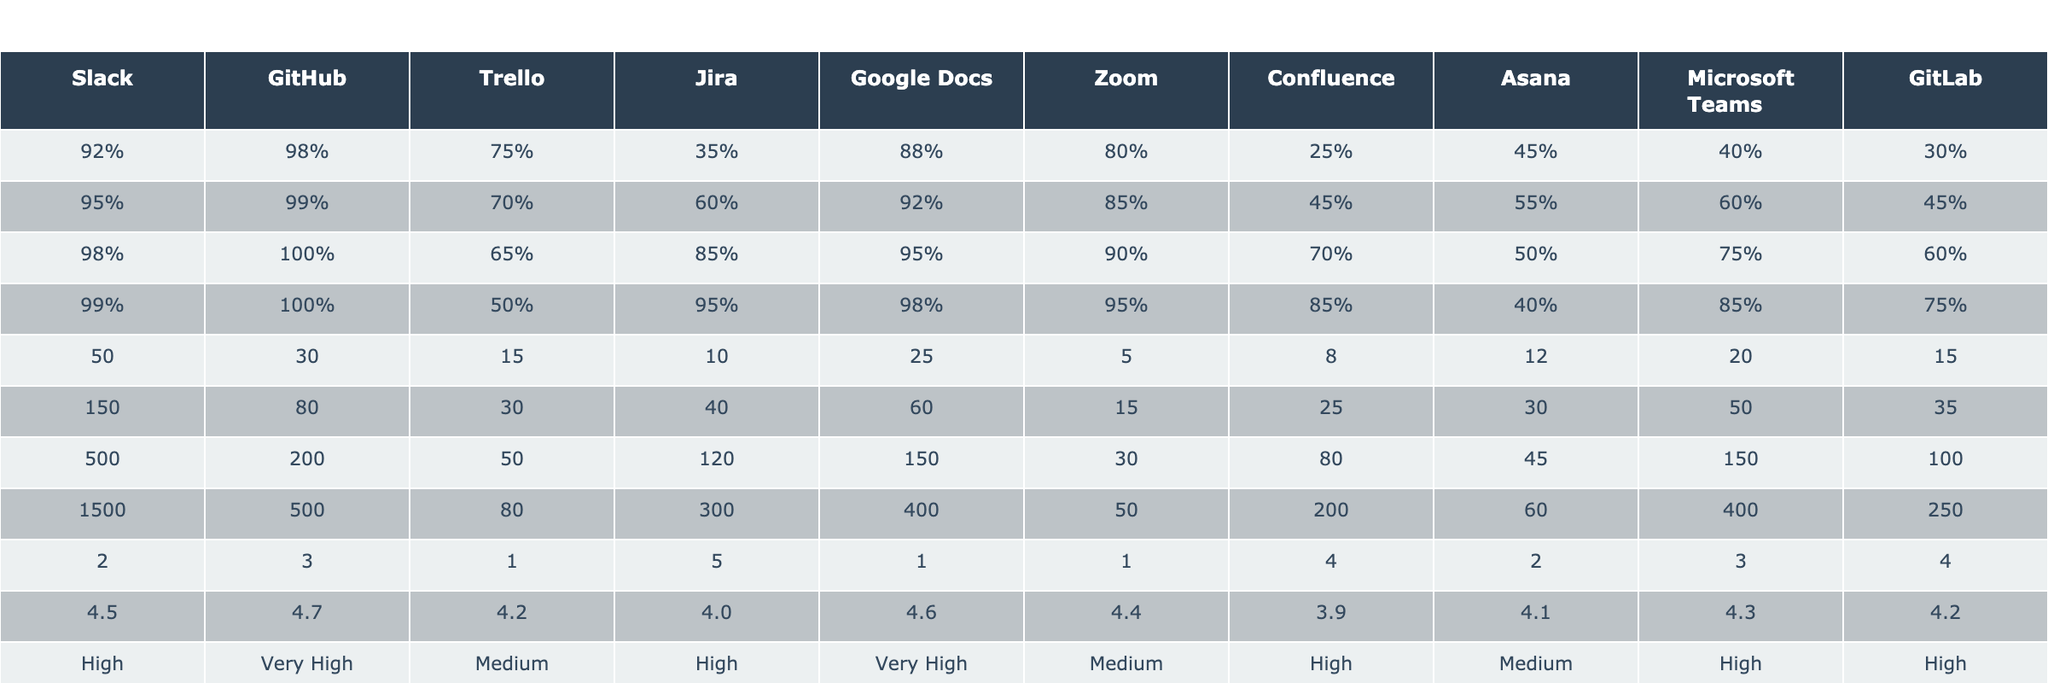What is the user satisfaction rating for Slack in small projects? According to the table, the user satisfaction rating for Slack is listed under the "User satisfaction rating" row for the "Small (1-10 members)" category, which shows a value of 4.5.
Answer: 4.5 Which collaboration tool has the highest percentage usage in enterprise projects? By looking at the percentage usage for each collaboration tool in the "Enterprise (201+ members)" row, Slack and GitHub both show a usage of 99% and 100% respectively, but GitHub has the highest at 100%.
Answer: GitHub What is the average daily number of messages for large projects using Trello? The table lists the average daily messages for Trello under the "Average daily messages" row for "Large (51-200 members)" and it shows a value of 50.
Answer: 50 Which project size has the lowest average onboarding time when using Google Docs? The onboarding times for Google Docs across project sizes are: 2 days for small, 1 day for medium, 1 day for large, and 1 day for enterprise. The smallest value is 1 day, which occurs in medium, large, and enterprise projects.
Answer: 1 day What is the difference in user satisfaction ratings between GitHub and Confluence for small projects? The user satisfaction rating for GitHub is 4.7 and for Confluence it is 3.9. The difference is calculated as 4.7 - 3.9 = 0.8.
Answer: 0.8 Is the integration of Asana with other tools rated high or medium? The table indicates that Asana's integration with other tools is categorized as "Medium."
Answer: Medium For medium-sized teams, which tool has both the highest average daily messages and a very high integration rating? The average daily messages for medium projects show Slack with 150 messages and its integration rating is "High." However, GitHub, with 80 messages, has a "Very High" integration rating. Therefore, Slack has the highest average daily messages.
Answer: Slack What is the average number of daily messages for small projects across all tools? The average daily messages for small projects are: Slack (50), GitHub (30), Trello (15), Jira (10), Google Docs (25), Zoom (5), Confluence (8), Asana (12), Microsoft Teams (20), and GitLab (15). The total is 50 + 30 + 15 + 10 + 25 + 5 + 8 + 12 + 20 + 15 = 250. Dividing this by the number of tools (10), the average is 250/10 = 25.
Answer: 25 Which collaboration tool shows the least user satisfaction among large project teams? In large project teams, the user satisfaction ratings are: Slack (4.5), GitHub (4.7), Trello (4.2), Jira (4.0), Google Docs (4.6), Zoom (4.4), Confluence (3.9), Asana (4.1), Microsoft Teams (4.3), and GitLab (4.2). Confluence has the lowest rating at 3.9.
Answer: Confluence Do all collaboration tools have an open-source friendliness rating? The "Open-source friendliness" ratings for all tools in the table show various levels, indicating that each of them has a rating. Thus, the answer is yes.
Answer: Yes How many days does the average onboarding time take for enterprise level projects using Jira? The table specifies the onboarding time for enterprise projects using Jira is listed as 5 days.
Answer: 5 days 